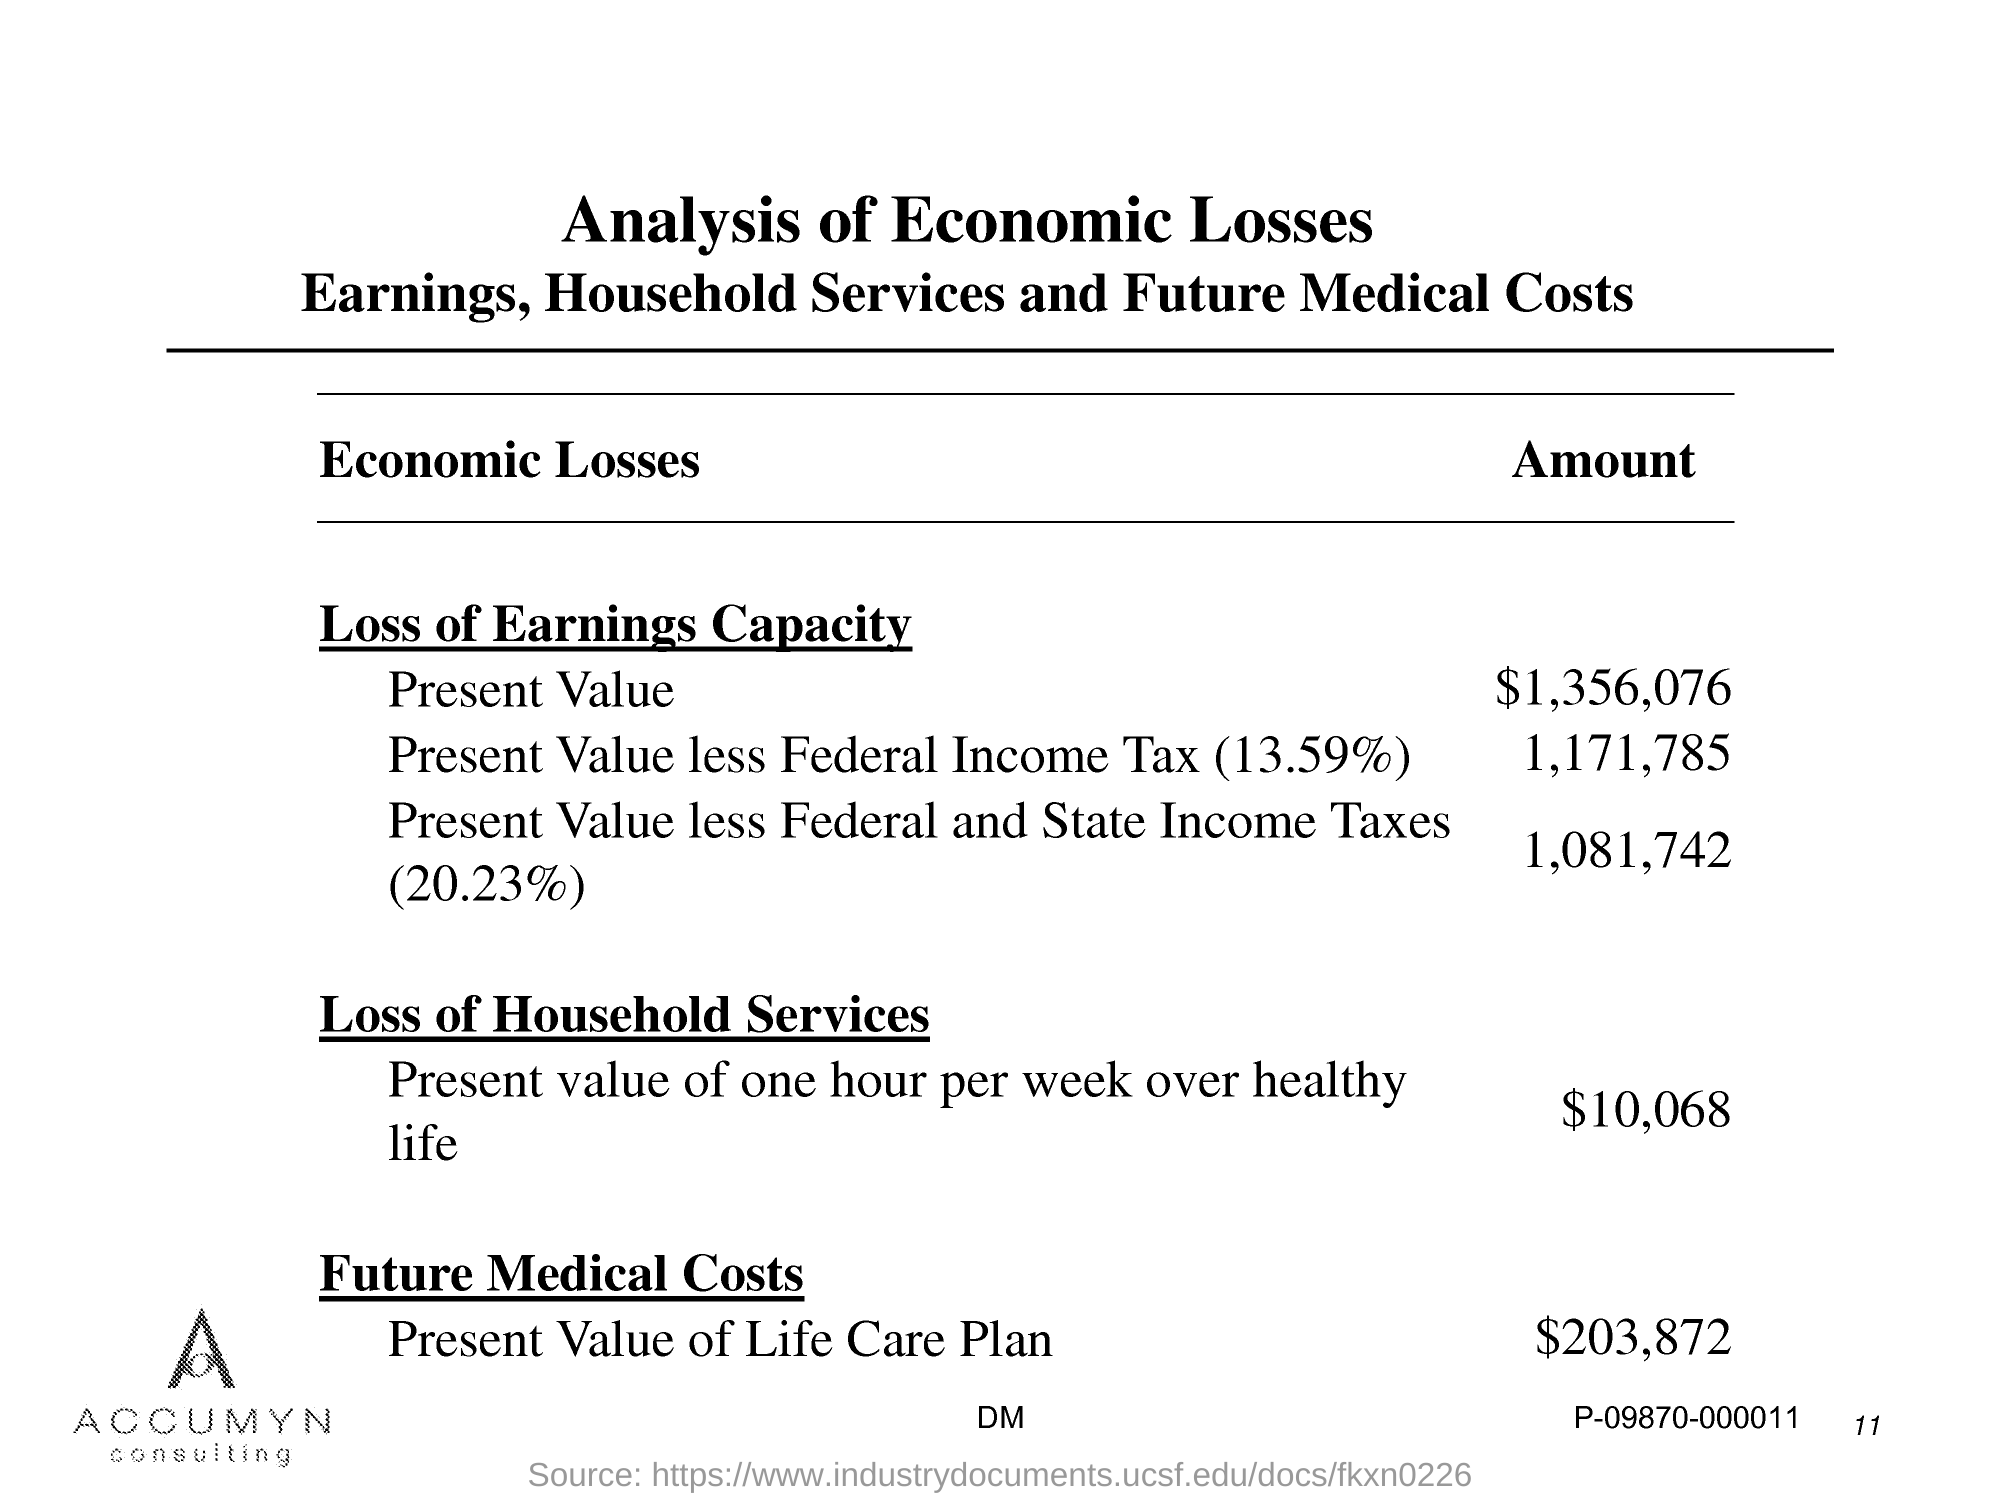Point out several critical features in this image. The present value of the life care plan is $203,872. The present value of $1,356,076 is [object object] [/object object]. The present value of one hour per week over a healthy life is $10,068. The present value, after deducting federal and state income taxes, is 1,081,742. The present value, minus federal income tax, is 1,171,785. 